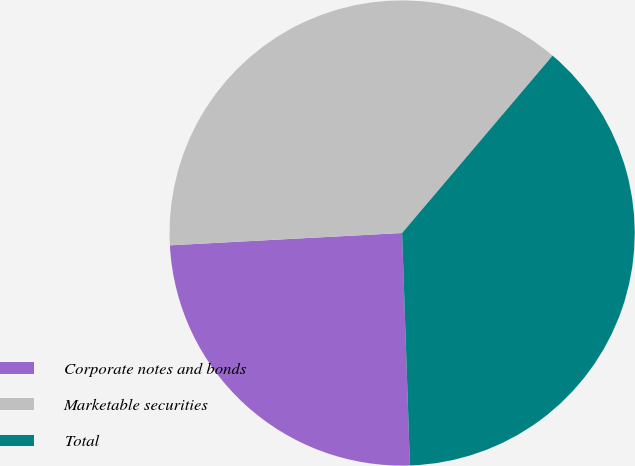<chart> <loc_0><loc_0><loc_500><loc_500><pie_chart><fcel>Corporate notes and bonds<fcel>Marketable securities<fcel>Total<nl><fcel>24.69%<fcel>37.04%<fcel>38.27%<nl></chart> 